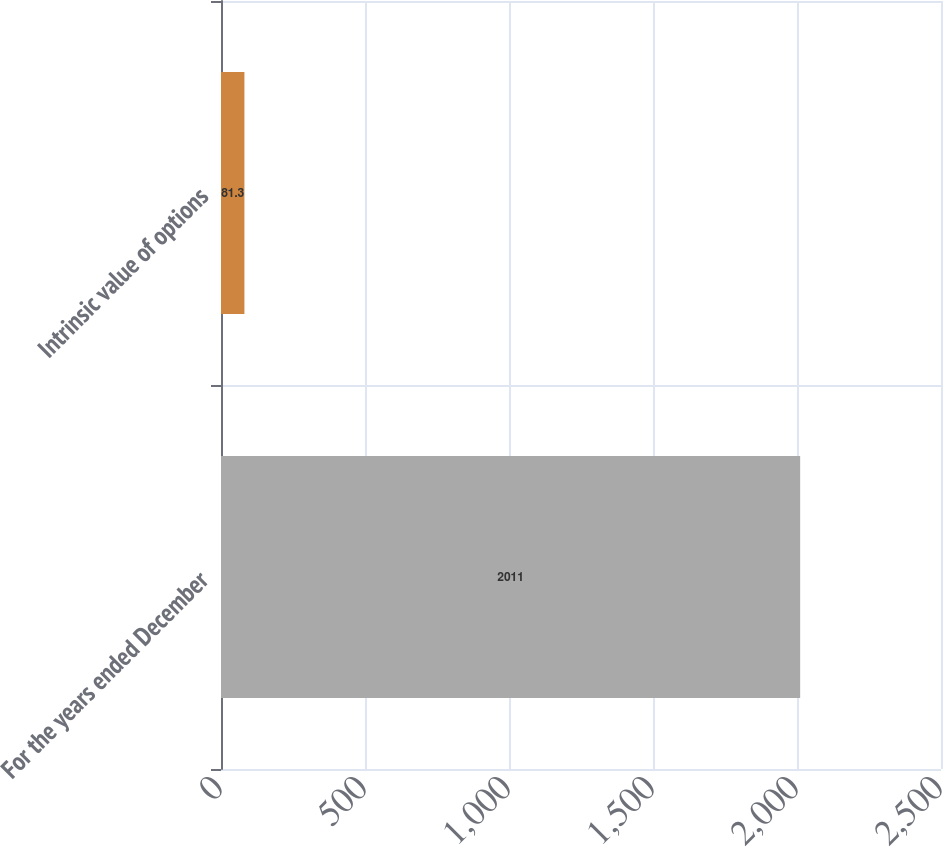<chart> <loc_0><loc_0><loc_500><loc_500><bar_chart><fcel>For the years ended December<fcel>Intrinsic value of options<nl><fcel>2011<fcel>81.3<nl></chart> 